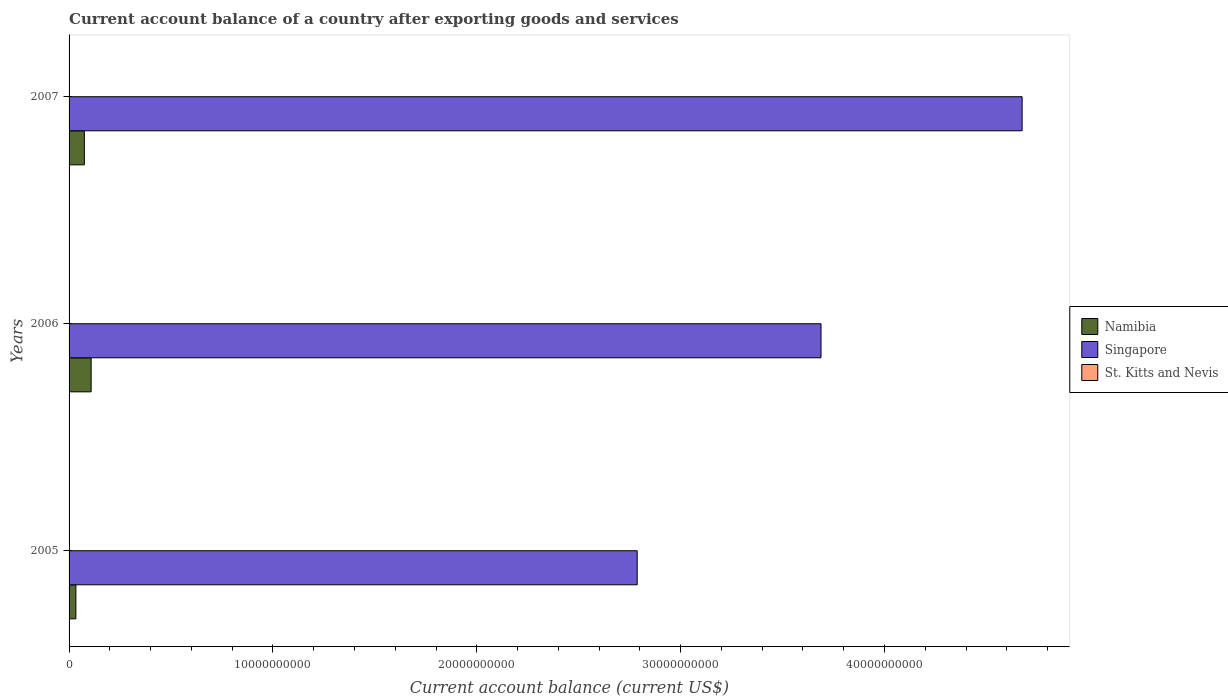How many different coloured bars are there?
Provide a short and direct response. 2. How many bars are there on the 2nd tick from the top?
Make the answer very short. 2. How many bars are there on the 3rd tick from the bottom?
Keep it short and to the point. 2. In how many cases, is the number of bars for a given year not equal to the number of legend labels?
Make the answer very short. 3. Across all years, what is the maximum account balance in Namibia?
Ensure brevity in your answer.  1.08e+09. Across all years, what is the minimum account balance in Singapore?
Your answer should be compact. 2.79e+1. In which year was the account balance in Singapore maximum?
Ensure brevity in your answer.  2007. What is the total account balance in Namibia in the graph?
Provide a succinct answer. 2.16e+09. What is the difference between the account balance in Singapore in 2005 and that in 2006?
Ensure brevity in your answer.  -9.02e+09. What is the difference between the account balance in Singapore in 2006 and the account balance in Namibia in 2007?
Give a very brief answer. 3.61e+1. What is the average account balance in Singapore per year?
Ensure brevity in your answer.  3.72e+1. What is the ratio of the account balance in Namibia in 2005 to that in 2006?
Ensure brevity in your answer.  0.31. What is the difference between the highest and the second highest account balance in Namibia?
Offer a very short reply. 3.34e+08. What is the difference between the highest and the lowest account balance in Singapore?
Your response must be concise. 1.89e+1. Is the sum of the account balance in Singapore in 2006 and 2007 greater than the maximum account balance in St. Kitts and Nevis across all years?
Ensure brevity in your answer.  Yes. How many bars are there?
Keep it short and to the point. 6. Are all the bars in the graph horizontal?
Offer a terse response. Yes. What is the difference between two consecutive major ticks on the X-axis?
Provide a succinct answer. 1.00e+1. Are the values on the major ticks of X-axis written in scientific E-notation?
Make the answer very short. No. Does the graph contain grids?
Provide a succinct answer. No. Where does the legend appear in the graph?
Offer a very short reply. Center right. How are the legend labels stacked?
Your response must be concise. Vertical. What is the title of the graph?
Your response must be concise. Current account balance of a country after exporting goods and services. What is the label or title of the X-axis?
Provide a short and direct response. Current account balance (current US$). What is the Current account balance (current US$) in Namibia in 2005?
Provide a short and direct response. 3.33e+08. What is the Current account balance (current US$) of Singapore in 2005?
Offer a terse response. 2.79e+1. What is the Current account balance (current US$) in St. Kitts and Nevis in 2005?
Offer a terse response. 0. What is the Current account balance (current US$) in Namibia in 2006?
Make the answer very short. 1.08e+09. What is the Current account balance (current US$) in Singapore in 2006?
Your answer should be very brief. 3.69e+1. What is the Current account balance (current US$) of Namibia in 2007?
Your response must be concise. 7.49e+08. What is the Current account balance (current US$) in Singapore in 2007?
Offer a very short reply. 4.67e+1. Across all years, what is the maximum Current account balance (current US$) in Namibia?
Offer a terse response. 1.08e+09. Across all years, what is the maximum Current account balance (current US$) of Singapore?
Ensure brevity in your answer.  4.67e+1. Across all years, what is the minimum Current account balance (current US$) in Namibia?
Your response must be concise. 3.33e+08. Across all years, what is the minimum Current account balance (current US$) of Singapore?
Keep it short and to the point. 2.79e+1. What is the total Current account balance (current US$) in Namibia in the graph?
Provide a short and direct response. 2.16e+09. What is the total Current account balance (current US$) of Singapore in the graph?
Provide a short and direct response. 1.12e+11. What is the total Current account balance (current US$) in St. Kitts and Nevis in the graph?
Keep it short and to the point. 0. What is the difference between the Current account balance (current US$) of Namibia in 2005 and that in 2006?
Give a very brief answer. -7.49e+08. What is the difference between the Current account balance (current US$) in Singapore in 2005 and that in 2006?
Make the answer very short. -9.02e+09. What is the difference between the Current account balance (current US$) of Namibia in 2005 and that in 2007?
Give a very brief answer. -4.15e+08. What is the difference between the Current account balance (current US$) of Singapore in 2005 and that in 2007?
Your response must be concise. -1.89e+1. What is the difference between the Current account balance (current US$) of Namibia in 2006 and that in 2007?
Provide a succinct answer. 3.34e+08. What is the difference between the Current account balance (current US$) of Singapore in 2006 and that in 2007?
Give a very brief answer. -9.86e+09. What is the difference between the Current account balance (current US$) of Namibia in 2005 and the Current account balance (current US$) of Singapore in 2006?
Provide a succinct answer. -3.66e+1. What is the difference between the Current account balance (current US$) of Namibia in 2005 and the Current account balance (current US$) of Singapore in 2007?
Provide a succinct answer. -4.64e+1. What is the difference between the Current account balance (current US$) of Namibia in 2006 and the Current account balance (current US$) of Singapore in 2007?
Offer a terse response. -4.57e+1. What is the average Current account balance (current US$) of Namibia per year?
Keep it short and to the point. 7.22e+08. What is the average Current account balance (current US$) of Singapore per year?
Offer a very short reply. 3.72e+1. What is the average Current account balance (current US$) in St. Kitts and Nevis per year?
Offer a terse response. 0. In the year 2005, what is the difference between the Current account balance (current US$) in Namibia and Current account balance (current US$) in Singapore?
Give a very brief answer. -2.75e+1. In the year 2006, what is the difference between the Current account balance (current US$) in Namibia and Current account balance (current US$) in Singapore?
Offer a terse response. -3.58e+1. In the year 2007, what is the difference between the Current account balance (current US$) of Namibia and Current account balance (current US$) of Singapore?
Offer a very short reply. -4.60e+1. What is the ratio of the Current account balance (current US$) of Namibia in 2005 to that in 2006?
Give a very brief answer. 0.31. What is the ratio of the Current account balance (current US$) in Singapore in 2005 to that in 2006?
Make the answer very short. 0.76. What is the ratio of the Current account balance (current US$) of Namibia in 2005 to that in 2007?
Provide a short and direct response. 0.45. What is the ratio of the Current account balance (current US$) in Singapore in 2005 to that in 2007?
Your answer should be very brief. 0.6. What is the ratio of the Current account balance (current US$) of Namibia in 2006 to that in 2007?
Provide a short and direct response. 1.45. What is the ratio of the Current account balance (current US$) of Singapore in 2006 to that in 2007?
Your answer should be compact. 0.79. What is the difference between the highest and the second highest Current account balance (current US$) in Namibia?
Your response must be concise. 3.34e+08. What is the difference between the highest and the second highest Current account balance (current US$) of Singapore?
Your answer should be compact. 9.86e+09. What is the difference between the highest and the lowest Current account balance (current US$) of Namibia?
Your answer should be very brief. 7.49e+08. What is the difference between the highest and the lowest Current account balance (current US$) of Singapore?
Your response must be concise. 1.89e+1. 